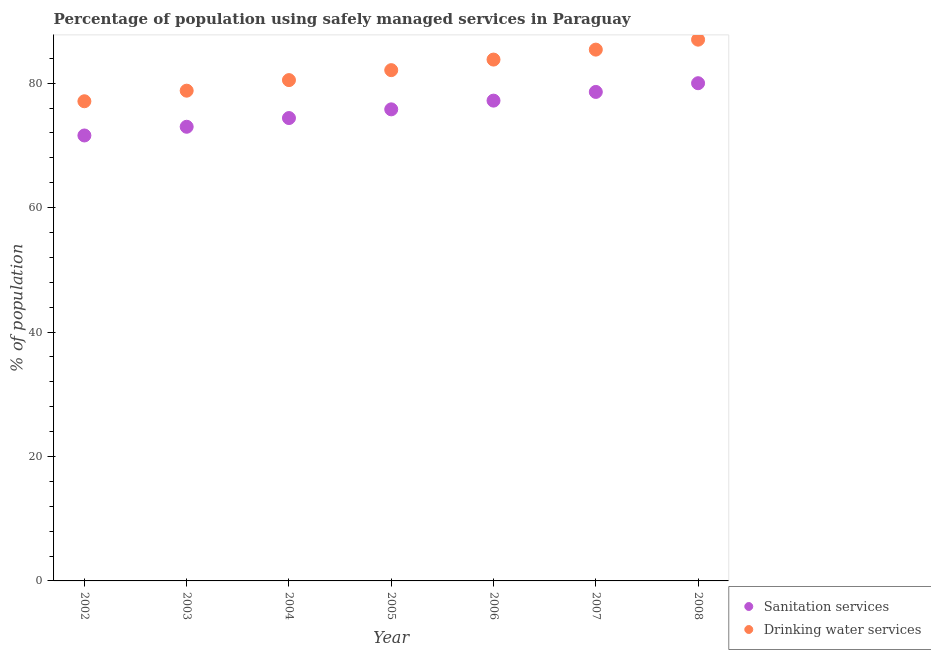How many different coloured dotlines are there?
Provide a short and direct response. 2. Is the number of dotlines equal to the number of legend labels?
Your response must be concise. Yes. What is the percentage of population who used sanitation services in 2007?
Your response must be concise. 78.6. Across all years, what is the minimum percentage of population who used drinking water services?
Keep it short and to the point. 77.1. In which year was the percentage of population who used drinking water services minimum?
Make the answer very short. 2002. What is the total percentage of population who used sanitation services in the graph?
Your answer should be very brief. 530.6. What is the difference between the percentage of population who used sanitation services in 2005 and that in 2008?
Offer a very short reply. -4.2. What is the difference between the percentage of population who used drinking water services in 2006 and the percentage of population who used sanitation services in 2008?
Give a very brief answer. 3.8. What is the average percentage of population who used sanitation services per year?
Ensure brevity in your answer.  75.8. In the year 2004, what is the difference between the percentage of population who used drinking water services and percentage of population who used sanitation services?
Provide a succinct answer. 6.1. In how many years, is the percentage of population who used sanitation services greater than 36 %?
Offer a terse response. 7. What is the ratio of the percentage of population who used sanitation services in 2003 to that in 2006?
Ensure brevity in your answer.  0.95. Is the difference between the percentage of population who used sanitation services in 2004 and 2008 greater than the difference between the percentage of population who used drinking water services in 2004 and 2008?
Make the answer very short. Yes. What is the difference between the highest and the second highest percentage of population who used drinking water services?
Make the answer very short. 1.6. What is the difference between the highest and the lowest percentage of population who used drinking water services?
Keep it short and to the point. 9.9. In how many years, is the percentage of population who used sanitation services greater than the average percentage of population who used sanitation services taken over all years?
Provide a short and direct response. 3. Is the percentage of population who used sanitation services strictly less than the percentage of population who used drinking water services over the years?
Ensure brevity in your answer.  Yes. What is the difference between two consecutive major ticks on the Y-axis?
Make the answer very short. 20. Are the values on the major ticks of Y-axis written in scientific E-notation?
Your answer should be very brief. No. Does the graph contain grids?
Your answer should be compact. No. How many legend labels are there?
Keep it short and to the point. 2. How are the legend labels stacked?
Ensure brevity in your answer.  Vertical. What is the title of the graph?
Ensure brevity in your answer.  Percentage of population using safely managed services in Paraguay. What is the label or title of the Y-axis?
Your answer should be compact. % of population. What is the % of population of Sanitation services in 2002?
Provide a succinct answer. 71.6. What is the % of population of Drinking water services in 2002?
Ensure brevity in your answer.  77.1. What is the % of population in Sanitation services in 2003?
Make the answer very short. 73. What is the % of population in Drinking water services in 2003?
Make the answer very short. 78.8. What is the % of population of Sanitation services in 2004?
Provide a succinct answer. 74.4. What is the % of population in Drinking water services in 2004?
Offer a terse response. 80.5. What is the % of population of Sanitation services in 2005?
Make the answer very short. 75.8. What is the % of population in Drinking water services in 2005?
Provide a short and direct response. 82.1. What is the % of population in Sanitation services in 2006?
Provide a short and direct response. 77.2. What is the % of population of Drinking water services in 2006?
Provide a short and direct response. 83.8. What is the % of population of Sanitation services in 2007?
Your response must be concise. 78.6. What is the % of population of Drinking water services in 2007?
Your response must be concise. 85.4. What is the % of population of Sanitation services in 2008?
Make the answer very short. 80. Across all years, what is the maximum % of population in Drinking water services?
Offer a very short reply. 87. Across all years, what is the minimum % of population in Sanitation services?
Your answer should be very brief. 71.6. Across all years, what is the minimum % of population in Drinking water services?
Make the answer very short. 77.1. What is the total % of population in Sanitation services in the graph?
Provide a short and direct response. 530.6. What is the total % of population in Drinking water services in the graph?
Your answer should be very brief. 574.7. What is the difference between the % of population in Sanitation services in 2002 and that in 2003?
Offer a very short reply. -1.4. What is the difference between the % of population of Sanitation services in 2002 and that in 2004?
Your answer should be compact. -2.8. What is the difference between the % of population of Sanitation services in 2002 and that in 2005?
Provide a short and direct response. -4.2. What is the difference between the % of population in Sanitation services in 2002 and that in 2007?
Give a very brief answer. -7. What is the difference between the % of population of Drinking water services in 2002 and that in 2007?
Offer a very short reply. -8.3. What is the difference between the % of population of Sanitation services in 2003 and that in 2004?
Your answer should be very brief. -1.4. What is the difference between the % of population in Drinking water services in 2003 and that in 2006?
Offer a terse response. -5. What is the difference between the % of population in Sanitation services in 2003 and that in 2007?
Your response must be concise. -5.6. What is the difference between the % of population in Drinking water services in 2003 and that in 2007?
Provide a succinct answer. -6.6. What is the difference between the % of population of Sanitation services in 2003 and that in 2008?
Keep it short and to the point. -7. What is the difference between the % of population in Drinking water services in 2004 and that in 2005?
Keep it short and to the point. -1.6. What is the difference between the % of population of Sanitation services in 2004 and that in 2006?
Offer a very short reply. -2.8. What is the difference between the % of population in Sanitation services in 2004 and that in 2007?
Ensure brevity in your answer.  -4.2. What is the difference between the % of population in Sanitation services in 2004 and that in 2008?
Keep it short and to the point. -5.6. What is the difference between the % of population in Drinking water services in 2004 and that in 2008?
Your response must be concise. -6.5. What is the difference between the % of population in Drinking water services in 2005 and that in 2007?
Give a very brief answer. -3.3. What is the difference between the % of population of Sanitation services in 2005 and that in 2008?
Give a very brief answer. -4.2. What is the difference between the % of population in Sanitation services in 2006 and that in 2008?
Ensure brevity in your answer.  -2.8. What is the difference between the % of population in Sanitation services in 2002 and the % of population in Drinking water services in 2003?
Give a very brief answer. -7.2. What is the difference between the % of population in Sanitation services in 2002 and the % of population in Drinking water services in 2004?
Your answer should be very brief. -8.9. What is the difference between the % of population in Sanitation services in 2002 and the % of population in Drinking water services in 2005?
Give a very brief answer. -10.5. What is the difference between the % of population of Sanitation services in 2002 and the % of population of Drinking water services in 2006?
Ensure brevity in your answer.  -12.2. What is the difference between the % of population in Sanitation services in 2002 and the % of population in Drinking water services in 2007?
Your response must be concise. -13.8. What is the difference between the % of population of Sanitation services in 2002 and the % of population of Drinking water services in 2008?
Ensure brevity in your answer.  -15.4. What is the difference between the % of population in Sanitation services in 2003 and the % of population in Drinking water services in 2004?
Your answer should be very brief. -7.5. What is the difference between the % of population of Sanitation services in 2003 and the % of population of Drinking water services in 2005?
Your response must be concise. -9.1. What is the difference between the % of population of Sanitation services in 2003 and the % of population of Drinking water services in 2006?
Keep it short and to the point. -10.8. What is the difference between the % of population of Sanitation services in 2003 and the % of population of Drinking water services in 2008?
Give a very brief answer. -14. What is the difference between the % of population of Sanitation services in 2004 and the % of population of Drinking water services in 2006?
Your answer should be very brief. -9.4. What is the difference between the % of population of Sanitation services in 2004 and the % of population of Drinking water services in 2008?
Offer a terse response. -12.6. What is the difference between the % of population in Sanitation services in 2005 and the % of population in Drinking water services in 2006?
Provide a succinct answer. -8. What is the difference between the % of population of Sanitation services in 2005 and the % of population of Drinking water services in 2008?
Offer a very short reply. -11.2. What is the average % of population of Sanitation services per year?
Your response must be concise. 75.8. What is the average % of population in Drinking water services per year?
Offer a very short reply. 82.1. In the year 2002, what is the difference between the % of population in Sanitation services and % of population in Drinking water services?
Your answer should be very brief. -5.5. In the year 2004, what is the difference between the % of population in Sanitation services and % of population in Drinking water services?
Your answer should be very brief. -6.1. In the year 2006, what is the difference between the % of population of Sanitation services and % of population of Drinking water services?
Provide a short and direct response. -6.6. In the year 2007, what is the difference between the % of population in Sanitation services and % of population in Drinking water services?
Your answer should be compact. -6.8. In the year 2008, what is the difference between the % of population in Sanitation services and % of population in Drinking water services?
Keep it short and to the point. -7. What is the ratio of the % of population of Sanitation services in 2002 to that in 2003?
Provide a short and direct response. 0.98. What is the ratio of the % of population of Drinking water services in 2002 to that in 2003?
Your answer should be compact. 0.98. What is the ratio of the % of population of Sanitation services in 2002 to that in 2004?
Make the answer very short. 0.96. What is the ratio of the % of population of Drinking water services in 2002 to that in 2004?
Your response must be concise. 0.96. What is the ratio of the % of population in Sanitation services in 2002 to that in 2005?
Your response must be concise. 0.94. What is the ratio of the % of population of Drinking water services in 2002 to that in 2005?
Your answer should be very brief. 0.94. What is the ratio of the % of population in Sanitation services in 2002 to that in 2006?
Keep it short and to the point. 0.93. What is the ratio of the % of population in Sanitation services in 2002 to that in 2007?
Make the answer very short. 0.91. What is the ratio of the % of population of Drinking water services in 2002 to that in 2007?
Your answer should be compact. 0.9. What is the ratio of the % of population of Sanitation services in 2002 to that in 2008?
Your response must be concise. 0.9. What is the ratio of the % of population of Drinking water services in 2002 to that in 2008?
Provide a succinct answer. 0.89. What is the ratio of the % of population of Sanitation services in 2003 to that in 2004?
Provide a succinct answer. 0.98. What is the ratio of the % of population of Drinking water services in 2003 to that in 2004?
Offer a terse response. 0.98. What is the ratio of the % of population of Sanitation services in 2003 to that in 2005?
Keep it short and to the point. 0.96. What is the ratio of the % of population in Drinking water services in 2003 to that in 2005?
Provide a short and direct response. 0.96. What is the ratio of the % of population of Sanitation services in 2003 to that in 2006?
Keep it short and to the point. 0.95. What is the ratio of the % of population of Drinking water services in 2003 to that in 2006?
Give a very brief answer. 0.94. What is the ratio of the % of population of Sanitation services in 2003 to that in 2007?
Offer a very short reply. 0.93. What is the ratio of the % of population of Drinking water services in 2003 to that in 2007?
Give a very brief answer. 0.92. What is the ratio of the % of population of Sanitation services in 2003 to that in 2008?
Provide a short and direct response. 0.91. What is the ratio of the % of population of Drinking water services in 2003 to that in 2008?
Make the answer very short. 0.91. What is the ratio of the % of population in Sanitation services in 2004 to that in 2005?
Keep it short and to the point. 0.98. What is the ratio of the % of population in Drinking water services in 2004 to that in 2005?
Ensure brevity in your answer.  0.98. What is the ratio of the % of population of Sanitation services in 2004 to that in 2006?
Provide a succinct answer. 0.96. What is the ratio of the % of population in Drinking water services in 2004 to that in 2006?
Keep it short and to the point. 0.96. What is the ratio of the % of population of Sanitation services in 2004 to that in 2007?
Offer a very short reply. 0.95. What is the ratio of the % of population in Drinking water services in 2004 to that in 2007?
Offer a terse response. 0.94. What is the ratio of the % of population of Drinking water services in 2004 to that in 2008?
Your answer should be compact. 0.93. What is the ratio of the % of population of Sanitation services in 2005 to that in 2006?
Provide a succinct answer. 0.98. What is the ratio of the % of population of Drinking water services in 2005 to that in 2006?
Provide a succinct answer. 0.98. What is the ratio of the % of population of Sanitation services in 2005 to that in 2007?
Offer a terse response. 0.96. What is the ratio of the % of population of Drinking water services in 2005 to that in 2007?
Keep it short and to the point. 0.96. What is the ratio of the % of population of Sanitation services in 2005 to that in 2008?
Your response must be concise. 0.95. What is the ratio of the % of population in Drinking water services in 2005 to that in 2008?
Make the answer very short. 0.94. What is the ratio of the % of population in Sanitation services in 2006 to that in 2007?
Ensure brevity in your answer.  0.98. What is the ratio of the % of population of Drinking water services in 2006 to that in 2007?
Make the answer very short. 0.98. What is the ratio of the % of population of Sanitation services in 2006 to that in 2008?
Provide a succinct answer. 0.96. What is the ratio of the % of population in Drinking water services in 2006 to that in 2008?
Provide a succinct answer. 0.96. What is the ratio of the % of population in Sanitation services in 2007 to that in 2008?
Your answer should be very brief. 0.98. What is the ratio of the % of population of Drinking water services in 2007 to that in 2008?
Your response must be concise. 0.98. 